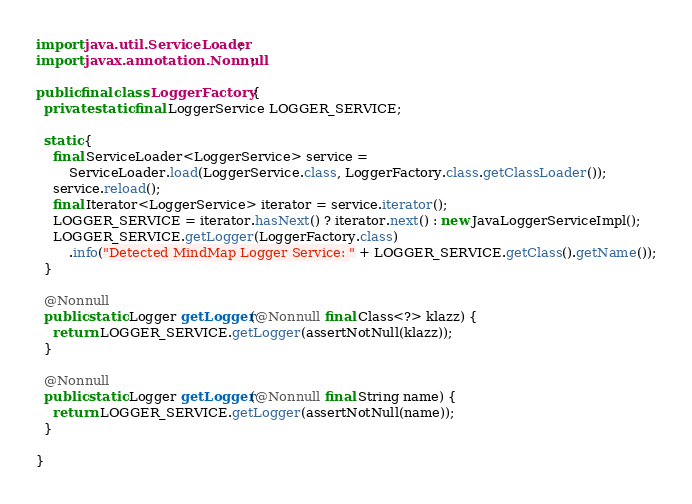Convert code to text. <code><loc_0><loc_0><loc_500><loc_500><_Java_>import java.util.ServiceLoader;
import javax.annotation.Nonnull;

public final class LoggerFactory {
  private static final LoggerService LOGGER_SERVICE;

  static {
    final ServiceLoader<LoggerService> service =
        ServiceLoader.load(LoggerService.class, LoggerFactory.class.getClassLoader());
    service.reload();
    final Iterator<LoggerService> iterator = service.iterator();
    LOGGER_SERVICE = iterator.hasNext() ? iterator.next() : new JavaLoggerServiceImpl();
    LOGGER_SERVICE.getLogger(LoggerFactory.class)
        .info("Detected MindMap Logger Service: " + LOGGER_SERVICE.getClass().getName());
  }

  @Nonnull
  public static Logger getLogger(@Nonnull final Class<?> klazz) {
    return LOGGER_SERVICE.getLogger(assertNotNull(klazz));
  }

  @Nonnull
  public static Logger getLogger(@Nonnull final String name) {
    return LOGGER_SERVICE.getLogger(assertNotNull(name));
  }

}
</code> 